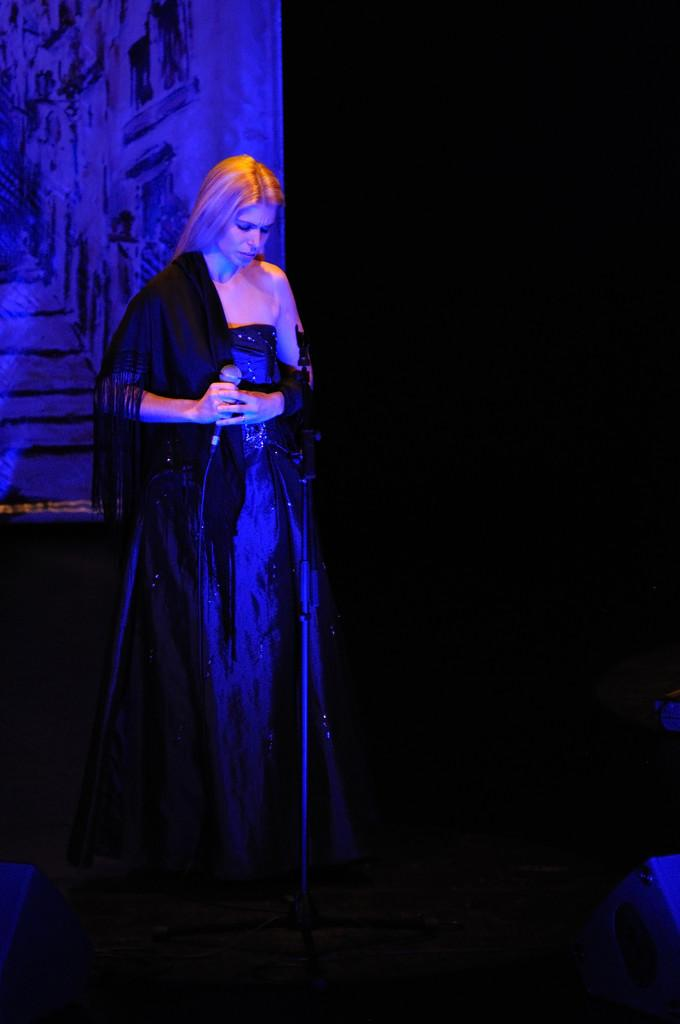Who is the main subject in the image? There is a woman in the image. What is the woman doing in the image? The woman is standing and holding a microphone. What else can be seen in the image besides the woman? There is a cloth in the image. How would you describe the background of the image? The background of the image is dark. What type of bomb is the woman holding in the image? There is no bomb present in the image; the woman is holding a microphone. How many slaves are visible in the image? There are no slaves present in the image; it features a woman holding a microphone. 